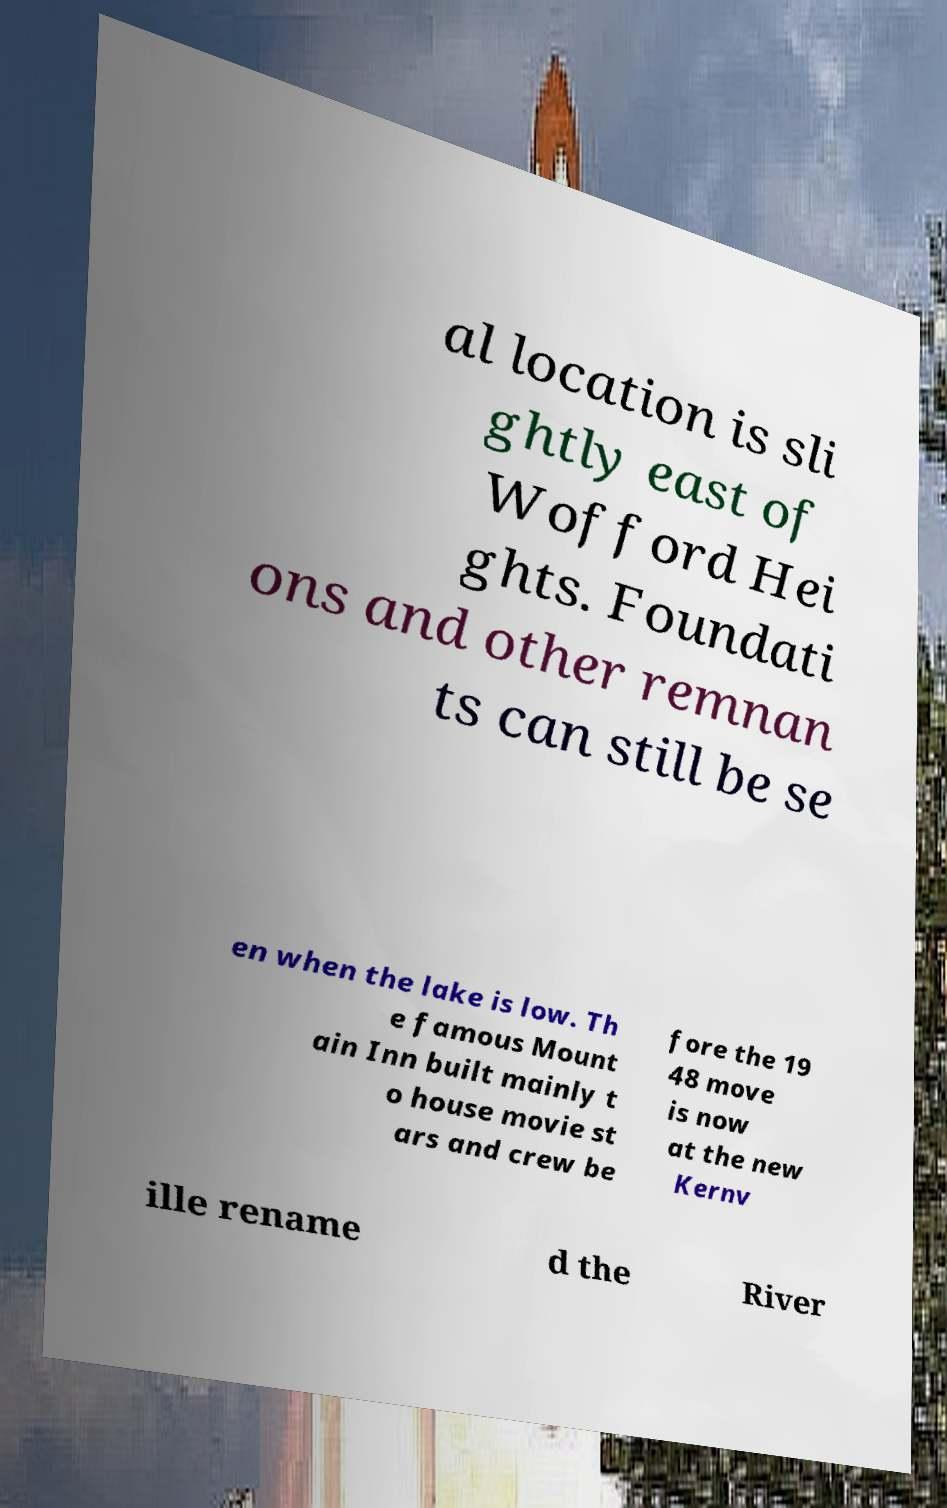Could you assist in decoding the text presented in this image and type it out clearly? al location is sli ghtly east of Wofford Hei ghts. Foundati ons and other remnan ts can still be se en when the lake is low. Th e famous Mount ain Inn built mainly t o house movie st ars and crew be fore the 19 48 move is now at the new Kernv ille rename d the River 